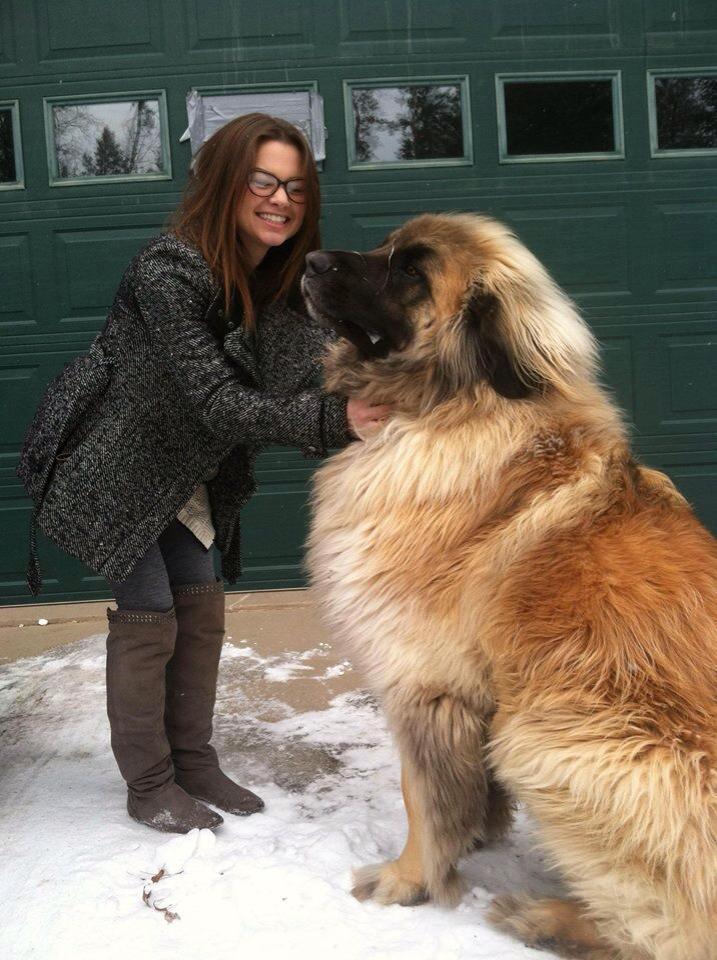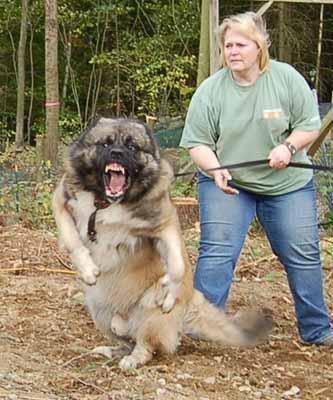The first image is the image on the left, the second image is the image on the right. For the images shown, is this caption "A little girl is holding a  large dog in the rightmost image." true? Answer yes or no. No. The first image is the image on the left, the second image is the image on the right. Evaluate the accuracy of this statement regarding the images: "There is one dog lying on the ground in the image on the right.". Is it true? Answer yes or no. No. 